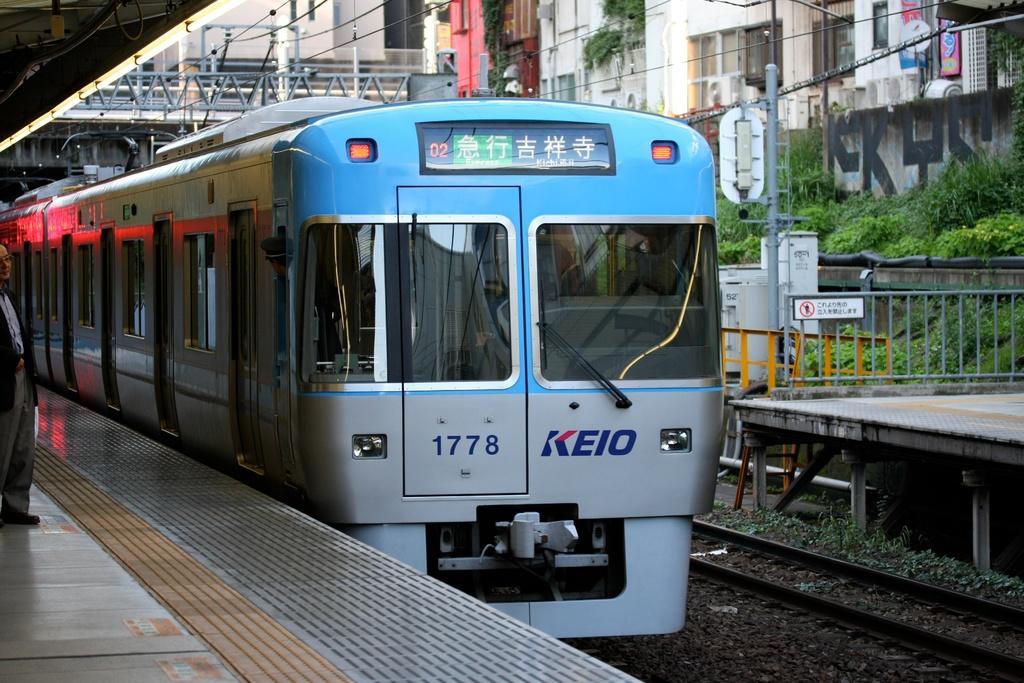How would you summarize this image in a sentence or two? In this image I can see a train which is blue and grey in color is on the track. I can see platforms on both sides of the train and another track on the ground. I can see a person standing on the platform, few metal rods, few poles, few boards, few buildings and few trees which are green in color. 